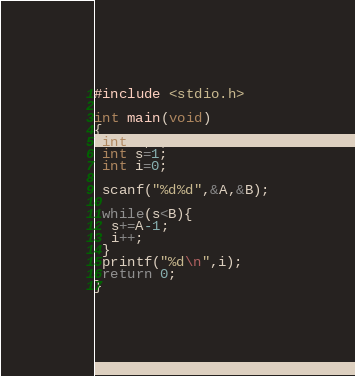Convert code to text. <code><loc_0><loc_0><loc_500><loc_500><_C_>#include <stdio.h>

int main(void)
{
 int A,B;
 int s=1;
 int i=0;

 scanf("%d%d",&A,&B);

 while(s<B){
  s+=A-1;
  i++;
 }
 printf("%d\n",i);
 return 0;
}

</code> 